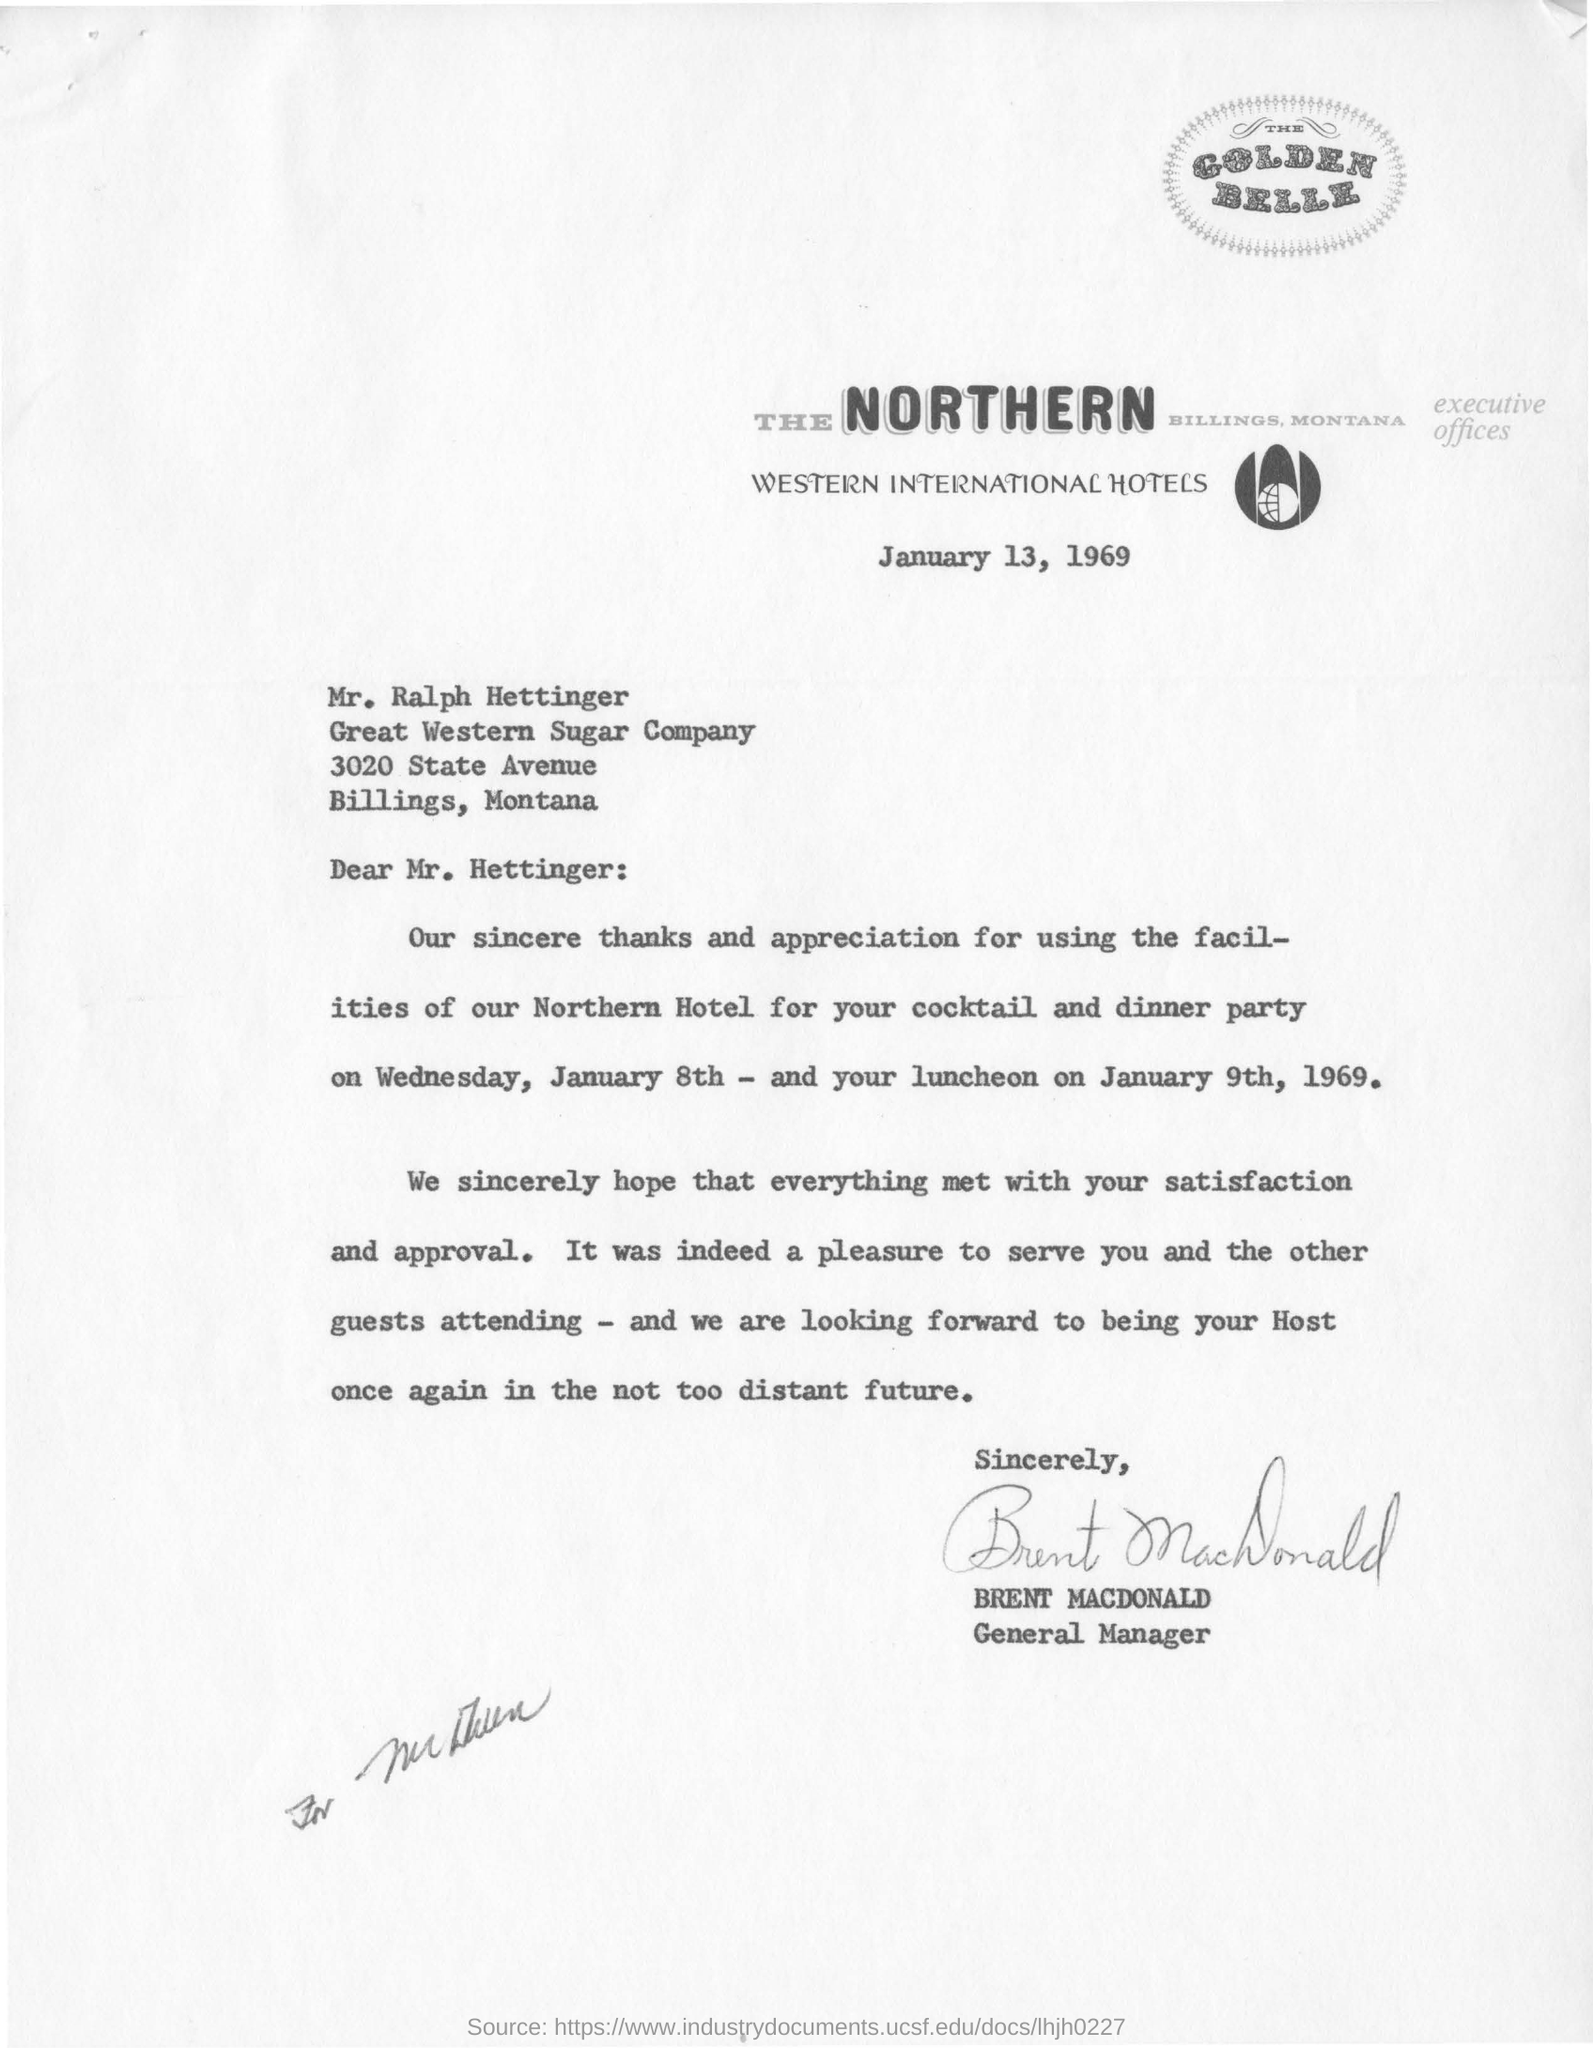Highlight a few significant elements in this photo. The letter is from Brent Macdonald. The letter was written on January 13, 1969. The letter is addressed to Mr. Hettinger. 